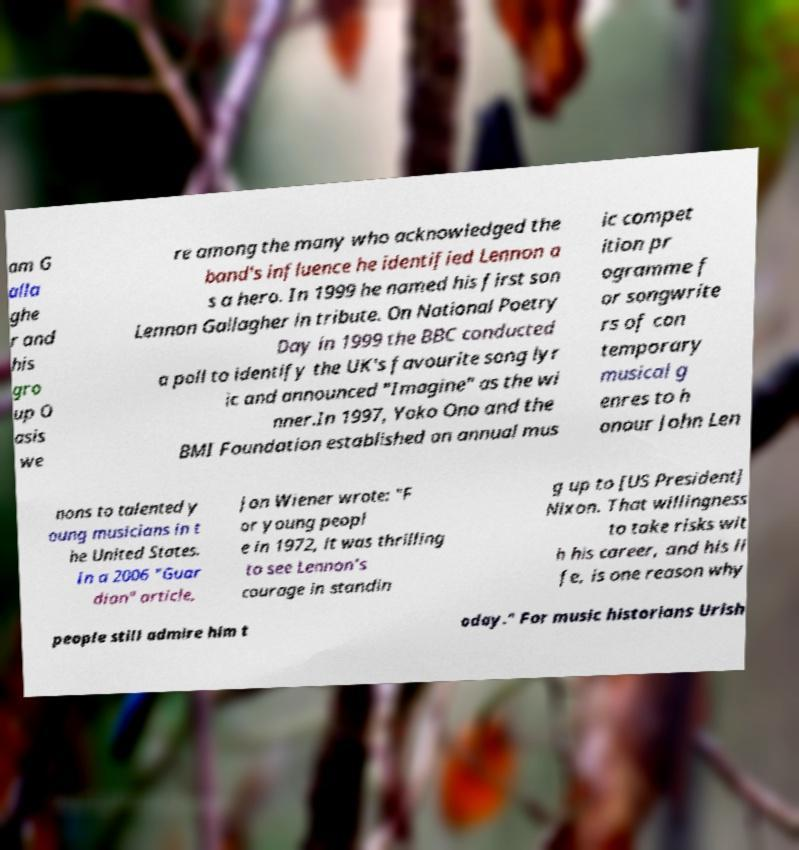I need the written content from this picture converted into text. Can you do that? am G alla ghe r and his gro up O asis we re among the many who acknowledged the band's influence he identified Lennon a s a hero. In 1999 he named his first son Lennon Gallagher in tribute. On National Poetry Day in 1999 the BBC conducted a poll to identify the UK's favourite song lyr ic and announced "Imagine" as the wi nner.In 1997, Yoko Ono and the BMI Foundation established an annual mus ic compet ition pr ogramme f or songwrite rs of con temporary musical g enres to h onour John Len nons to talented y oung musicians in t he United States. In a 2006 "Guar dian" article, Jon Wiener wrote: "F or young peopl e in 1972, it was thrilling to see Lennon's courage in standin g up to [US President] Nixon. That willingness to take risks wit h his career, and his li fe, is one reason why people still admire him t oday." For music historians Urish 